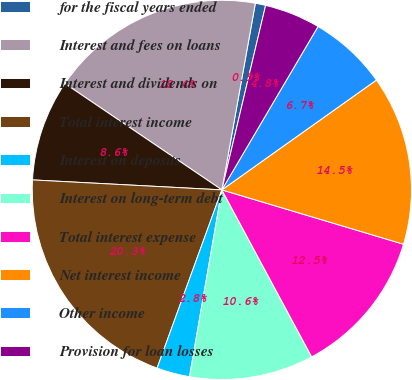Convert chart to OTSL. <chart><loc_0><loc_0><loc_500><loc_500><pie_chart><fcel>for the fiscal years ended<fcel>Interest and fees on loans<fcel>Interest and dividends on<fcel>Total interest income<fcel>Interest on deposits<fcel>Interest on long-term debt<fcel>Total interest expense<fcel>Net interest income<fcel>Other income<fcel>Provision for loan losses<nl><fcel>0.88%<fcel>18.35%<fcel>8.64%<fcel>20.29%<fcel>2.82%<fcel>10.58%<fcel>12.52%<fcel>14.46%<fcel>6.7%<fcel>4.76%<nl></chart> 